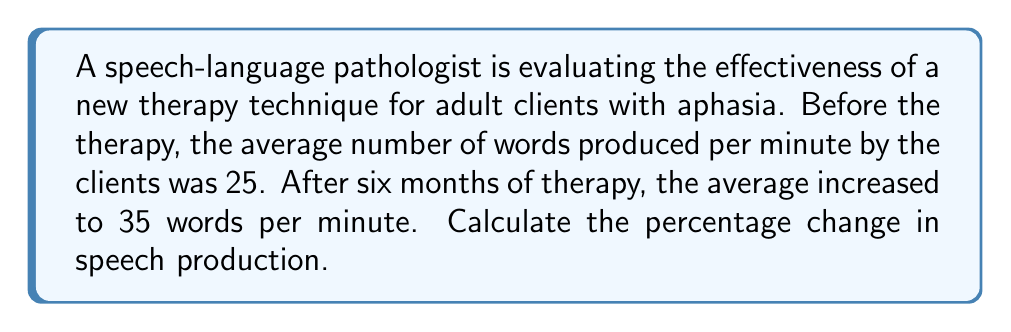Solve this math problem. To calculate the percentage change, we need to follow these steps:

1. Calculate the change in value:
   New value - Original value = $35 - 25 = 10$ words per minute

2. Divide the change by the original value:
   $\frac{\text{Change}}{\text{Original value}} = \frac{10}{25} = 0.4$

3. Convert the decimal to a percentage by multiplying by 100:
   $0.4 \times 100 = 40\%$

The formula for percentage change is:

$$\text{Percentage Change} = \frac{\text{New Value} - \text{Original Value}}{\text{Original Value}} \times 100\%$$

Plugging in our values:

$$\text{Percentage Change} = \frac{35 - 25}{25} \times 100\% = \frac{10}{25} \times 100\% = 0.4 \times 100\% = 40\%$$

Therefore, the percentage change in speech production is a 40% increase.
Answer: 40% increase 